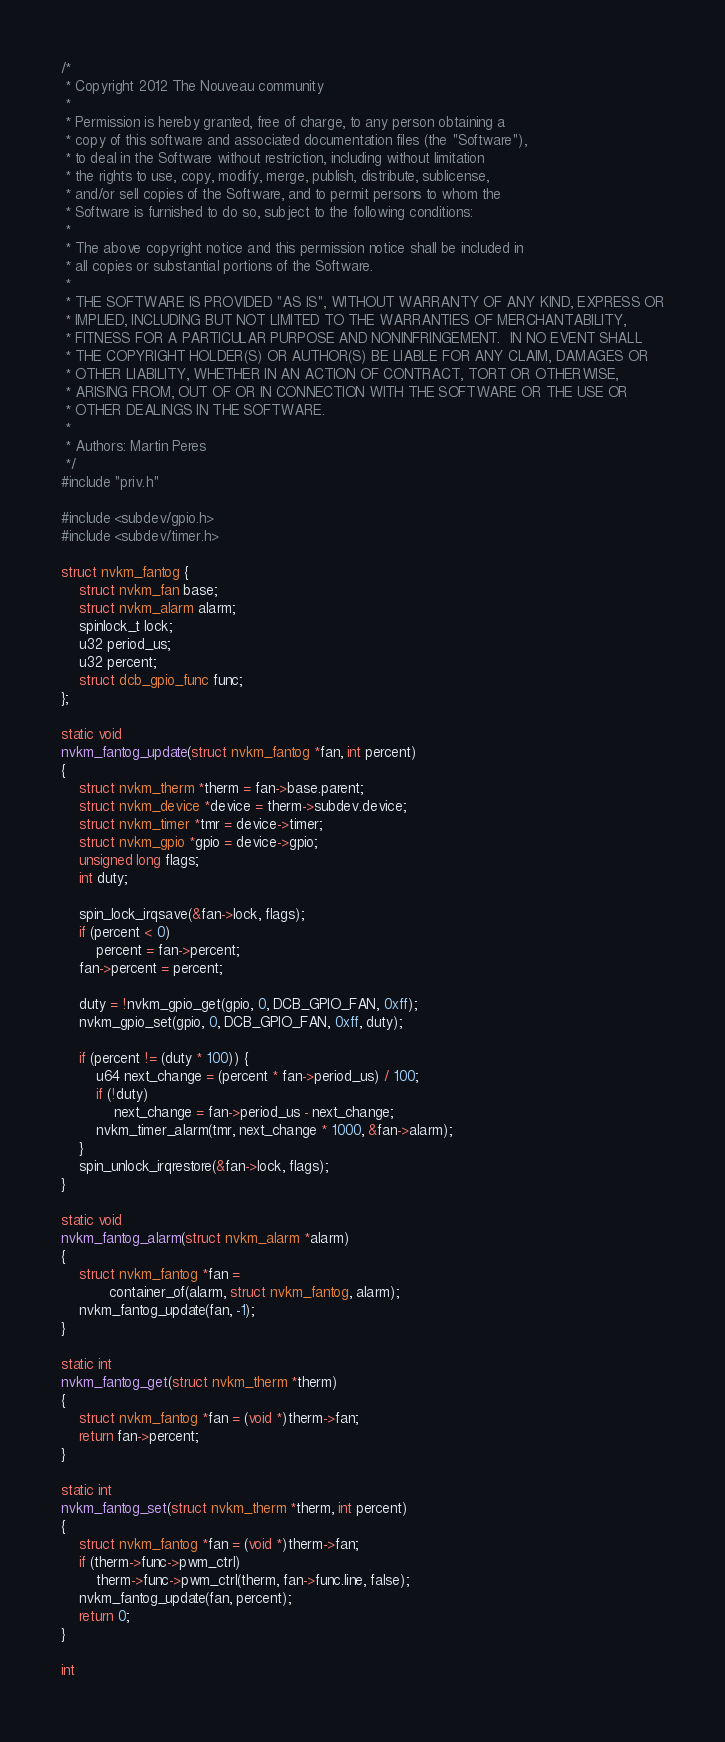Convert code to text. <code><loc_0><loc_0><loc_500><loc_500><_C_>/*
 * Copyright 2012 The Nouveau community
 *
 * Permission is hereby granted, free of charge, to any person obtaining a
 * copy of this software and associated documentation files (the "Software"),
 * to deal in the Software without restriction, including without limitation
 * the rights to use, copy, modify, merge, publish, distribute, sublicense,
 * and/or sell copies of the Software, and to permit persons to whom the
 * Software is furnished to do so, subject to the following conditions:
 *
 * The above copyright notice and this permission notice shall be included in
 * all copies or substantial portions of the Software.
 *
 * THE SOFTWARE IS PROVIDED "AS IS", WITHOUT WARRANTY OF ANY KIND, EXPRESS OR
 * IMPLIED, INCLUDING BUT NOT LIMITED TO THE WARRANTIES OF MERCHANTABILITY,
 * FITNESS FOR A PARTICULAR PURPOSE AND NONINFRINGEMENT.  IN NO EVENT SHALL
 * THE COPYRIGHT HOLDER(S) OR AUTHOR(S) BE LIABLE FOR ANY CLAIM, DAMAGES OR
 * OTHER LIABILITY, WHETHER IN AN ACTION OF CONTRACT, TORT OR OTHERWISE,
 * ARISING FROM, OUT OF OR IN CONNECTION WITH THE SOFTWARE OR THE USE OR
 * OTHER DEALINGS IN THE SOFTWARE.
 *
 * Authors: Martin Peres
 */
#include "priv.h"

#include <subdev/gpio.h>
#include <subdev/timer.h>

struct nvkm_fantog {
	struct nvkm_fan base;
	struct nvkm_alarm alarm;
	spinlock_t lock;
	u32 period_us;
	u32 percent;
	struct dcb_gpio_func func;
};

static void
nvkm_fantog_update(struct nvkm_fantog *fan, int percent)
{
	struct nvkm_therm *therm = fan->base.parent;
	struct nvkm_device *device = therm->subdev.device;
	struct nvkm_timer *tmr = device->timer;
	struct nvkm_gpio *gpio = device->gpio;
	unsigned long flags;
	int duty;

	spin_lock_irqsave(&fan->lock, flags);
	if (percent < 0)
		percent = fan->percent;
	fan->percent = percent;

	duty = !nvkm_gpio_get(gpio, 0, DCB_GPIO_FAN, 0xff);
	nvkm_gpio_set(gpio, 0, DCB_GPIO_FAN, 0xff, duty);

	if (percent != (duty * 100)) {
		u64 next_change = (percent * fan->period_us) / 100;
		if (!duty)
			next_change = fan->period_us - next_change;
		nvkm_timer_alarm(tmr, next_change * 1000, &fan->alarm);
	}
	spin_unlock_irqrestore(&fan->lock, flags);
}

static void
nvkm_fantog_alarm(struct nvkm_alarm *alarm)
{
	struct nvkm_fantog *fan =
	       container_of(alarm, struct nvkm_fantog, alarm);
	nvkm_fantog_update(fan, -1);
}

static int
nvkm_fantog_get(struct nvkm_therm *therm)
{
	struct nvkm_fantog *fan = (void *)therm->fan;
	return fan->percent;
}

static int
nvkm_fantog_set(struct nvkm_therm *therm, int percent)
{
	struct nvkm_fantog *fan = (void *)therm->fan;
	if (therm->func->pwm_ctrl)
		therm->func->pwm_ctrl(therm, fan->func.line, false);
	nvkm_fantog_update(fan, percent);
	return 0;
}

int</code> 